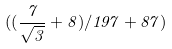<formula> <loc_0><loc_0><loc_500><loc_500>( ( \frac { 7 } { \sqrt { 3 } } + 8 ) / 1 9 7 + 8 7 )</formula> 